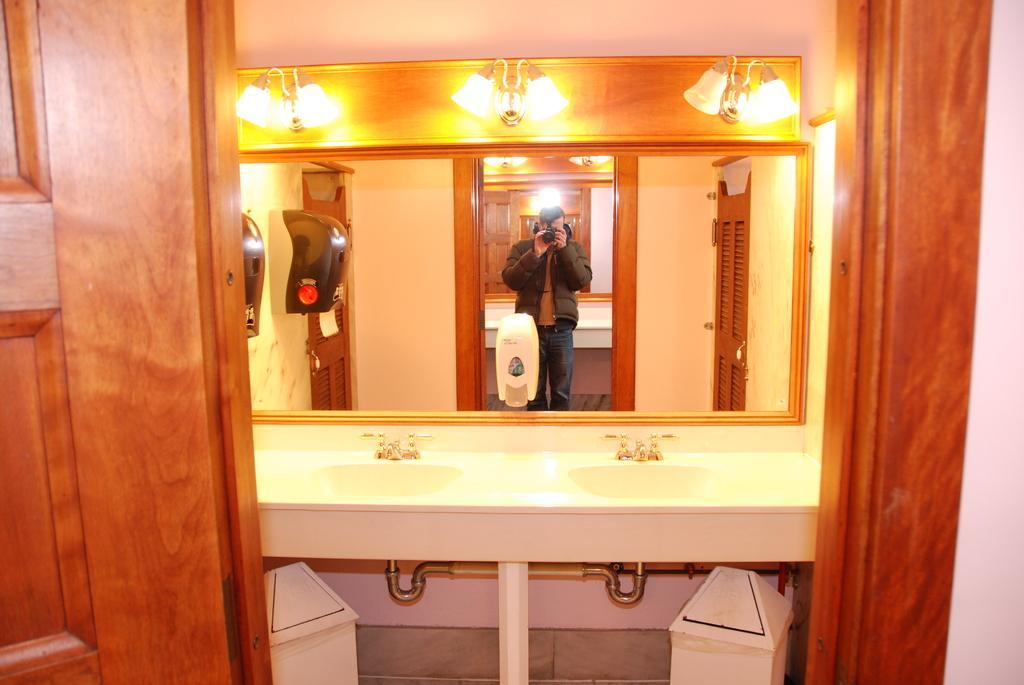Can you describe this image briefly? This is a picture clicked in washroom. In the foreground there are doors. In the center of the picture there are lights, mirror, sinks, pipes and dustbin. In the mirror we can see a person holding camera. 